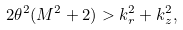<formula> <loc_0><loc_0><loc_500><loc_500>2 \theta ^ { 2 } ( M ^ { 2 } + 2 ) > k _ { r } ^ { 2 } + k _ { z } ^ { 2 } ,</formula> 